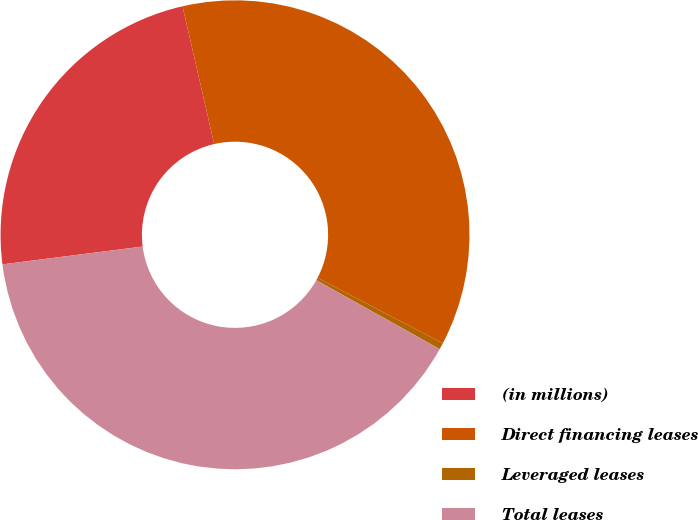<chart> <loc_0><loc_0><loc_500><loc_500><pie_chart><fcel>(in millions)<fcel>Direct financing leases<fcel>Leveraged leases<fcel>Total leases<nl><fcel>23.42%<fcel>36.25%<fcel>0.45%<fcel>39.88%<nl></chart> 